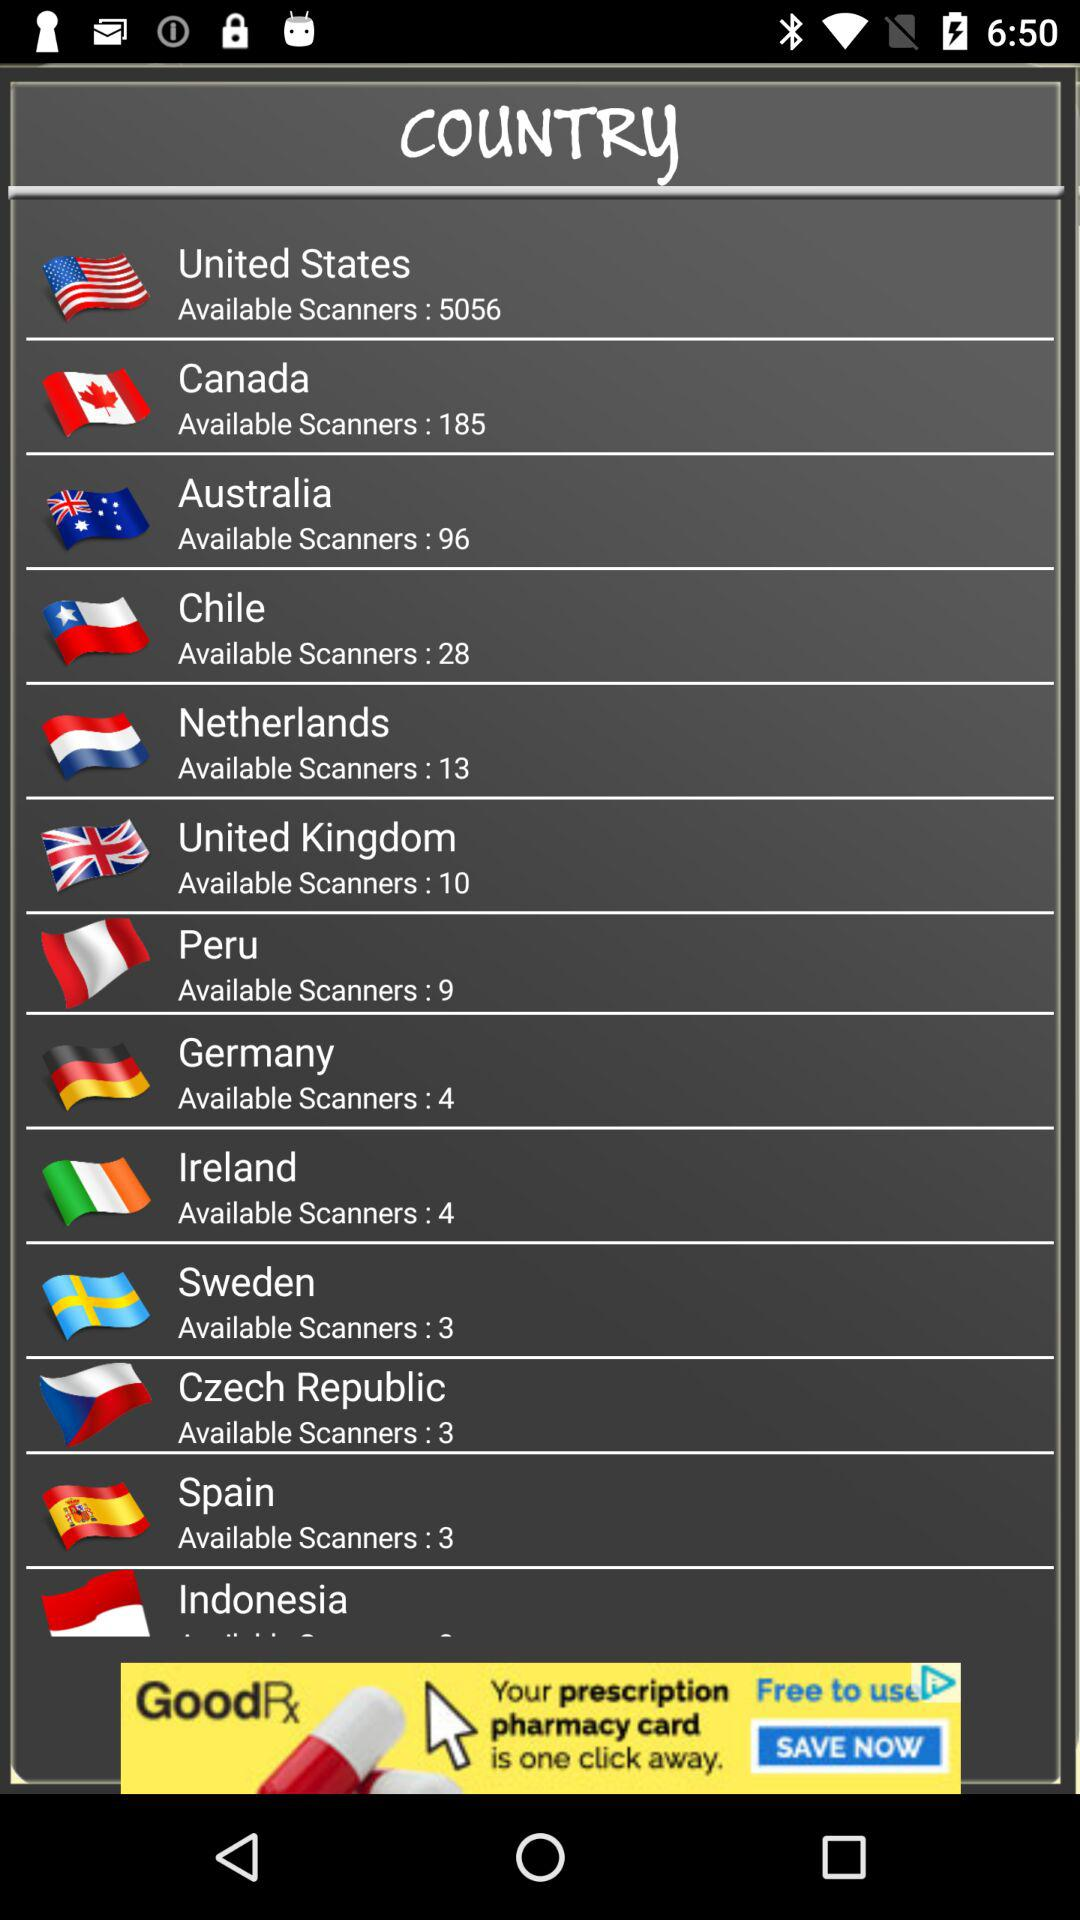How many scanners are available in Peru? There are 9 available scanners. 